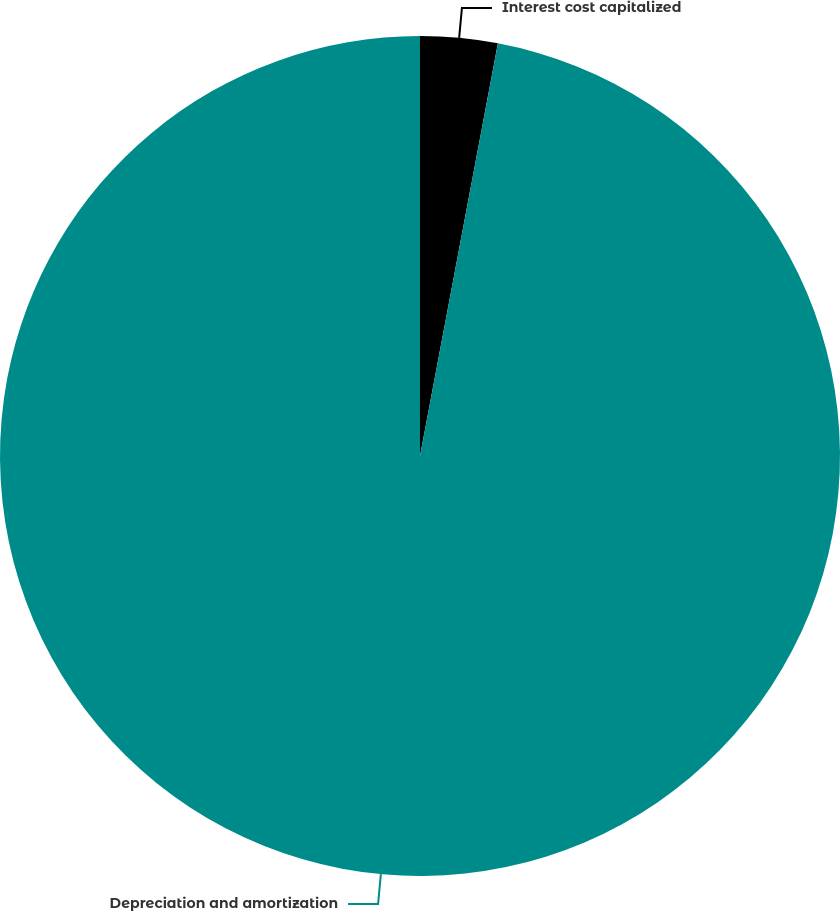Convert chart. <chart><loc_0><loc_0><loc_500><loc_500><pie_chart><fcel>Interest cost capitalized<fcel>Depreciation and amortization<nl><fcel>2.97%<fcel>97.03%<nl></chart> 